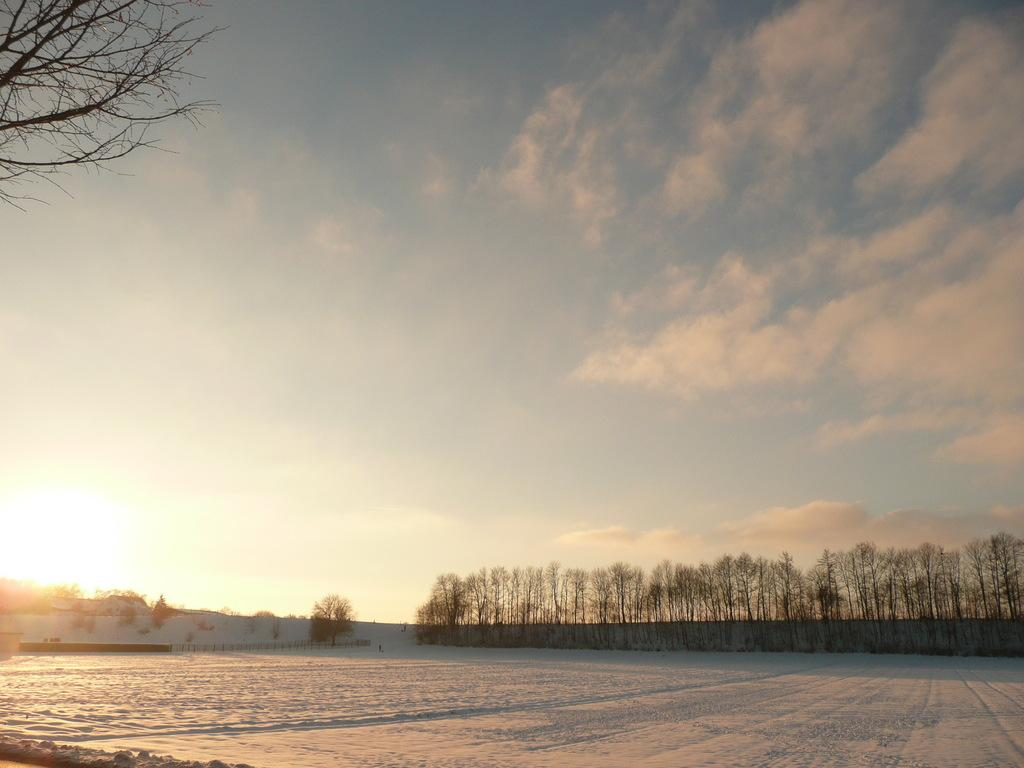What is the primary weather condition depicted in the image? There is snow in the image, indicating a wintery or cold weather condition. What type of structure can be seen in the image? There is fencing in the image. What type of natural vegetation is present in the image? There are trees in the image. What is the condition of the sky in the image? The sky is clouded in the image. What type of soup is being served in the image? There is no soup present in the image; it features snow, fencing, trees, and a clouded sky. What is the angle of the trees in the image? The angle of the trees cannot be determined from the image, as it only provides a two-dimensional representation. 